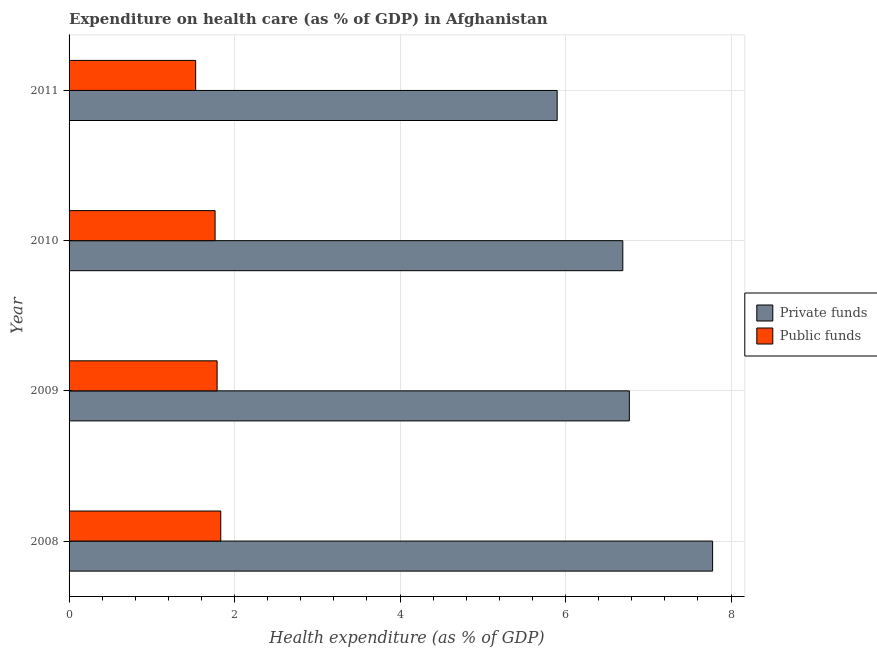How many groups of bars are there?
Make the answer very short. 4. In how many cases, is the number of bars for a given year not equal to the number of legend labels?
Give a very brief answer. 0. What is the amount of public funds spent in healthcare in 2008?
Offer a terse response. 1.83. Across all years, what is the maximum amount of private funds spent in healthcare?
Provide a succinct answer. 7.78. Across all years, what is the minimum amount of public funds spent in healthcare?
Provide a short and direct response. 1.53. In which year was the amount of private funds spent in healthcare minimum?
Give a very brief answer. 2011. What is the total amount of private funds spent in healthcare in the graph?
Make the answer very short. 27.14. What is the difference between the amount of private funds spent in healthcare in 2010 and that in 2011?
Your answer should be very brief. 0.79. What is the difference between the amount of private funds spent in healthcare in 2008 and the amount of public funds spent in healthcare in 2010?
Offer a very short reply. 6.01. What is the average amount of private funds spent in healthcare per year?
Make the answer very short. 6.78. In the year 2010, what is the difference between the amount of public funds spent in healthcare and amount of private funds spent in healthcare?
Give a very brief answer. -4.93. What is the ratio of the amount of private funds spent in healthcare in 2009 to that in 2011?
Ensure brevity in your answer.  1.15. What is the difference between the highest and the second highest amount of public funds spent in healthcare?
Keep it short and to the point. 0.04. What is the difference between the highest and the lowest amount of public funds spent in healthcare?
Your response must be concise. 0.3. In how many years, is the amount of private funds spent in healthcare greater than the average amount of private funds spent in healthcare taken over all years?
Provide a short and direct response. 1. What does the 1st bar from the top in 2009 represents?
Your answer should be compact. Public funds. What does the 2nd bar from the bottom in 2010 represents?
Your answer should be very brief. Public funds. How many bars are there?
Keep it short and to the point. 8. Are all the bars in the graph horizontal?
Give a very brief answer. Yes. What is the difference between two consecutive major ticks on the X-axis?
Your answer should be very brief. 2. Does the graph contain any zero values?
Keep it short and to the point. No. What is the title of the graph?
Your response must be concise. Expenditure on health care (as % of GDP) in Afghanistan. What is the label or title of the X-axis?
Keep it short and to the point. Health expenditure (as % of GDP). What is the Health expenditure (as % of GDP) of Private funds in 2008?
Offer a very short reply. 7.78. What is the Health expenditure (as % of GDP) of Public funds in 2008?
Provide a short and direct response. 1.83. What is the Health expenditure (as % of GDP) of Private funds in 2009?
Offer a very short reply. 6.77. What is the Health expenditure (as % of GDP) in Public funds in 2009?
Offer a very short reply. 1.79. What is the Health expenditure (as % of GDP) of Private funds in 2010?
Offer a very short reply. 6.69. What is the Health expenditure (as % of GDP) of Public funds in 2010?
Your answer should be very brief. 1.76. What is the Health expenditure (as % of GDP) in Private funds in 2011?
Your answer should be compact. 5.9. What is the Health expenditure (as % of GDP) in Public funds in 2011?
Your answer should be compact. 1.53. Across all years, what is the maximum Health expenditure (as % of GDP) of Private funds?
Provide a short and direct response. 7.78. Across all years, what is the maximum Health expenditure (as % of GDP) in Public funds?
Your response must be concise. 1.83. Across all years, what is the minimum Health expenditure (as % of GDP) in Private funds?
Your answer should be compact. 5.9. Across all years, what is the minimum Health expenditure (as % of GDP) in Public funds?
Ensure brevity in your answer.  1.53. What is the total Health expenditure (as % of GDP) of Private funds in the graph?
Your answer should be compact. 27.14. What is the total Health expenditure (as % of GDP) of Public funds in the graph?
Your answer should be very brief. 6.92. What is the difference between the Health expenditure (as % of GDP) of Private funds in 2008 and that in 2009?
Offer a terse response. 1.01. What is the difference between the Health expenditure (as % of GDP) in Public funds in 2008 and that in 2009?
Offer a terse response. 0.04. What is the difference between the Health expenditure (as % of GDP) of Private funds in 2008 and that in 2010?
Your answer should be compact. 1.09. What is the difference between the Health expenditure (as % of GDP) of Public funds in 2008 and that in 2010?
Make the answer very short. 0.07. What is the difference between the Health expenditure (as % of GDP) of Private funds in 2008 and that in 2011?
Your answer should be very brief. 1.88. What is the difference between the Health expenditure (as % of GDP) of Public funds in 2008 and that in 2011?
Ensure brevity in your answer.  0.3. What is the difference between the Health expenditure (as % of GDP) of Private funds in 2009 and that in 2010?
Ensure brevity in your answer.  0.08. What is the difference between the Health expenditure (as % of GDP) in Public funds in 2009 and that in 2010?
Offer a terse response. 0.02. What is the difference between the Health expenditure (as % of GDP) in Private funds in 2009 and that in 2011?
Give a very brief answer. 0.87. What is the difference between the Health expenditure (as % of GDP) in Public funds in 2009 and that in 2011?
Your response must be concise. 0.26. What is the difference between the Health expenditure (as % of GDP) of Private funds in 2010 and that in 2011?
Give a very brief answer. 0.79. What is the difference between the Health expenditure (as % of GDP) of Public funds in 2010 and that in 2011?
Keep it short and to the point. 0.23. What is the difference between the Health expenditure (as % of GDP) of Private funds in 2008 and the Health expenditure (as % of GDP) of Public funds in 2009?
Provide a succinct answer. 5.99. What is the difference between the Health expenditure (as % of GDP) of Private funds in 2008 and the Health expenditure (as % of GDP) of Public funds in 2010?
Offer a terse response. 6.01. What is the difference between the Health expenditure (as % of GDP) of Private funds in 2008 and the Health expenditure (as % of GDP) of Public funds in 2011?
Ensure brevity in your answer.  6.25. What is the difference between the Health expenditure (as % of GDP) in Private funds in 2009 and the Health expenditure (as % of GDP) in Public funds in 2010?
Keep it short and to the point. 5.01. What is the difference between the Health expenditure (as % of GDP) in Private funds in 2009 and the Health expenditure (as % of GDP) in Public funds in 2011?
Provide a succinct answer. 5.24. What is the difference between the Health expenditure (as % of GDP) of Private funds in 2010 and the Health expenditure (as % of GDP) of Public funds in 2011?
Give a very brief answer. 5.16. What is the average Health expenditure (as % of GDP) of Private funds per year?
Provide a succinct answer. 6.78. What is the average Health expenditure (as % of GDP) of Public funds per year?
Ensure brevity in your answer.  1.73. In the year 2008, what is the difference between the Health expenditure (as % of GDP) of Private funds and Health expenditure (as % of GDP) of Public funds?
Offer a very short reply. 5.94. In the year 2009, what is the difference between the Health expenditure (as % of GDP) of Private funds and Health expenditure (as % of GDP) of Public funds?
Your response must be concise. 4.98. In the year 2010, what is the difference between the Health expenditure (as % of GDP) of Private funds and Health expenditure (as % of GDP) of Public funds?
Your response must be concise. 4.93. In the year 2011, what is the difference between the Health expenditure (as % of GDP) of Private funds and Health expenditure (as % of GDP) of Public funds?
Keep it short and to the point. 4.37. What is the ratio of the Health expenditure (as % of GDP) in Private funds in 2008 to that in 2009?
Your answer should be compact. 1.15. What is the ratio of the Health expenditure (as % of GDP) in Public funds in 2008 to that in 2009?
Ensure brevity in your answer.  1.02. What is the ratio of the Health expenditure (as % of GDP) in Private funds in 2008 to that in 2010?
Your answer should be very brief. 1.16. What is the ratio of the Health expenditure (as % of GDP) of Public funds in 2008 to that in 2010?
Ensure brevity in your answer.  1.04. What is the ratio of the Health expenditure (as % of GDP) in Private funds in 2008 to that in 2011?
Your answer should be compact. 1.32. What is the ratio of the Health expenditure (as % of GDP) in Public funds in 2008 to that in 2011?
Provide a short and direct response. 1.2. What is the ratio of the Health expenditure (as % of GDP) in Private funds in 2009 to that in 2010?
Your response must be concise. 1.01. What is the ratio of the Health expenditure (as % of GDP) of Public funds in 2009 to that in 2010?
Your answer should be very brief. 1.01. What is the ratio of the Health expenditure (as % of GDP) of Private funds in 2009 to that in 2011?
Your answer should be compact. 1.15. What is the ratio of the Health expenditure (as % of GDP) in Public funds in 2009 to that in 2011?
Make the answer very short. 1.17. What is the ratio of the Health expenditure (as % of GDP) of Private funds in 2010 to that in 2011?
Give a very brief answer. 1.13. What is the ratio of the Health expenditure (as % of GDP) of Public funds in 2010 to that in 2011?
Your answer should be very brief. 1.15. What is the difference between the highest and the second highest Health expenditure (as % of GDP) in Public funds?
Offer a terse response. 0.04. What is the difference between the highest and the lowest Health expenditure (as % of GDP) in Private funds?
Make the answer very short. 1.88. What is the difference between the highest and the lowest Health expenditure (as % of GDP) in Public funds?
Offer a terse response. 0.3. 